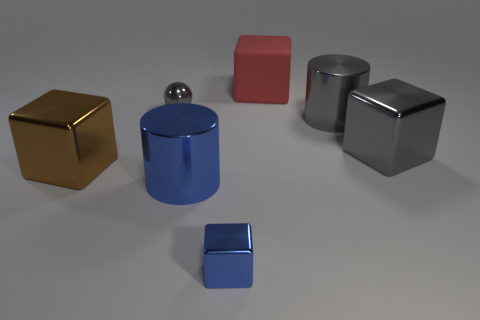Subtract all cyan blocks. Subtract all gray balls. How many blocks are left? 4 Add 3 yellow cubes. How many objects exist? 10 Subtract all spheres. How many objects are left? 6 Add 5 large shiny cylinders. How many large shiny cylinders are left? 7 Add 4 big red shiny spheres. How many big red shiny spheres exist? 4 Subtract 0 brown balls. How many objects are left? 7 Subtract all cylinders. Subtract all gray spheres. How many objects are left? 4 